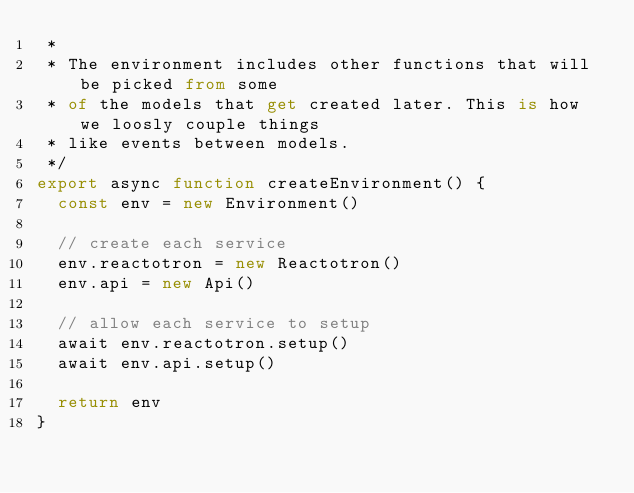<code> <loc_0><loc_0><loc_500><loc_500><_TypeScript_> *
 * The environment includes other functions that will be picked from some
 * of the models that get created later. This is how we loosly couple things
 * like events between models.
 */
export async function createEnvironment() {
  const env = new Environment()

  // create each service
  env.reactotron = new Reactotron()
  env.api = new Api()

  // allow each service to setup
  await env.reactotron.setup()
  await env.api.setup()

  return env
}
</code> 